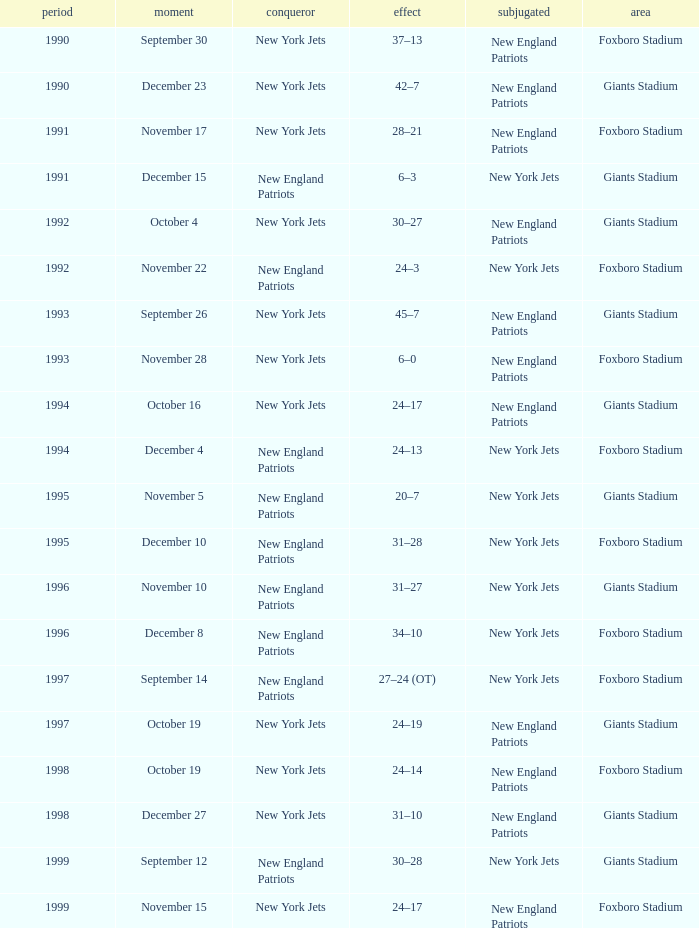What is the name of the Loser when the winner was new england patriots, and a Location of giants stadium, and a Result of 30–28? New York Jets. 